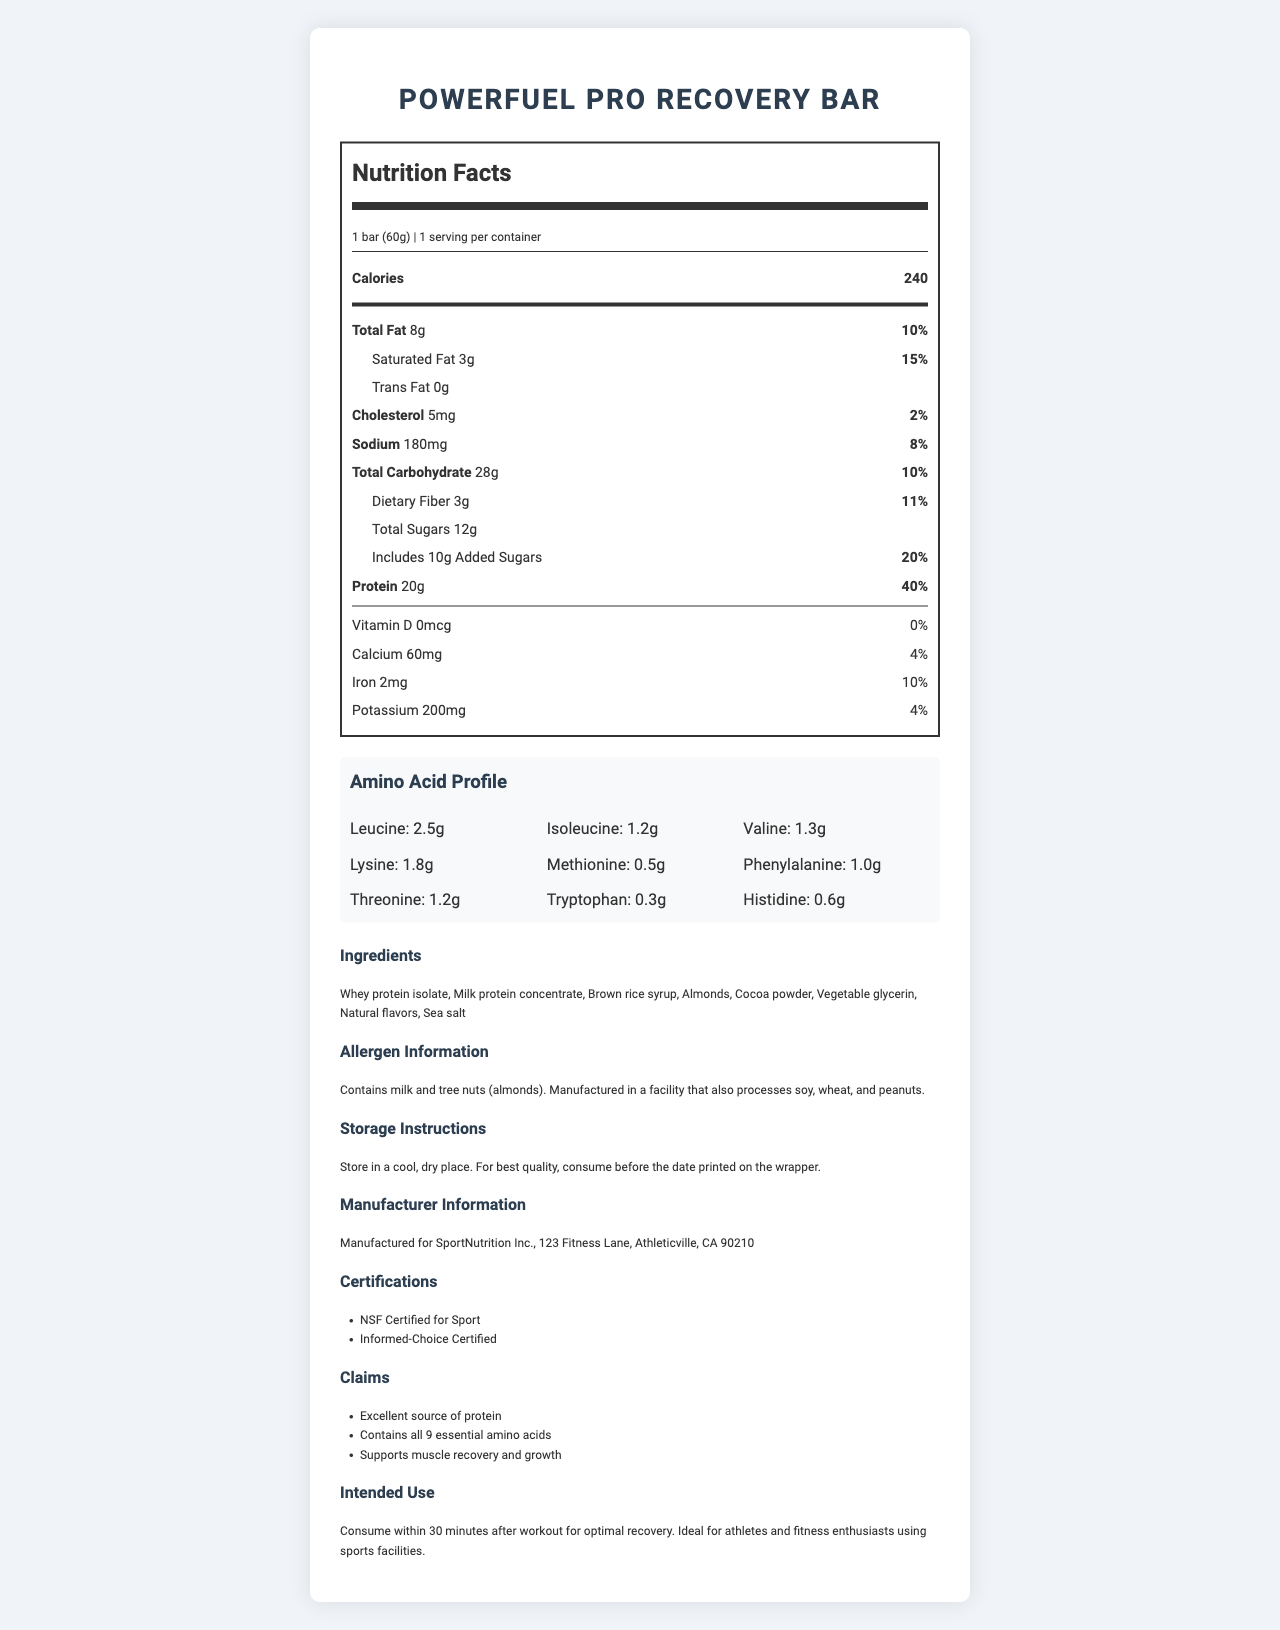what is the serving size of PowerFuel Pro Recovery Bar? According to the nutrition label, the serving size is 1 bar, which weighs 60g.
Answer: 1 bar (60g) How many grams of protein are in one serving? The nutrition label indicates that each serving of the protein bar contains 20 grams of protein.
Answer: 20g What is the percentage daily value of sodium for one serving? The nutrition label shows that the sodium content is 180mg per serving, which is 8% of the daily value.
Answer: 8% Which amino acid is present in the highest amount? The amino acid profile section indicates that Leucine is present in the highest amount, with 2.5 grams per serving.
Answer: Leucine, 2.5g How much dietary fiber does the bar contain? The nutrition facts specify that the bar contains 3 grams of dietary fiber per serving.
Answer: 3g What ingredients are in the PowerFuel Pro Recovery Bar? The ingredient list in the document provides this information.
Answer: Whey protein isolate, Milk protein concentrate, Brown rice syrup, Almonds, Cocoa powder, Vegetable glycerin, Natural flavors, Sea salt How many calories are in one PowerFuel Pro Recovery Bar? The nutrition label mentions that one serving of the bar contains 240 calories.
Answer: 240 calories Which certification does this product have? A. USDA Organic B. NSF Certified for Sport C. Fair Trade Certified The document lists NSF Certified for Sport as one of the certifications that the product has.
Answer: B What is the intended use of this protein bar? A. Before bedtime B. As a meal replacement C. Within 30 minutes after workout The intended use specified in the document is to consume within 30 minutes after a workout for optimal recovery.
Answer: C Does the PowerFuel Pro Recovery Bar contain peanuts? According to the allergen information, the bar contains milk and tree nuts (almonds) but does not list peanuts as an ingredient. However, it is manufactured in a facility that processes peanuts.
Answer: No Does this product provide any Vitamin D? The nutrition facts state that the bar has 0mcg of Vitamin D, equating to 0% of the daily value.
Answer: No Summarize the main purpose of the PowerFuel Pro Recovery Bar document. The detailed nutritional information, ingredient list, amino acid profile, and claims indicate that the bar is designed to support muscle recovery and growth for athletes and fitness enthusiasts.
Answer: The document details the nutritional composition, ingredients, amino acid profile, and usage instructions for the PowerFuel Pro Recovery Bar, emphasizing its role in post-workout recovery due to its high protein content and essential amino acids. What is the amount of calcium in one serving of the bar? The nutrition label indicates that there are 60mg of calcium per serving.
Answer: 60mg Which statement is NOT correct according to the document? A. The bar contains milk. B. The bar is suitable for a keto diet. C. The bar supports muscle recovery. The document does not mention that the bar is suitable for a keto diet. It focuses on muscle recovery and growth.
Answer: B What is the main source of protein in the PowerFuel Pro Recovery Bar? The ingredient list identifies whey protein isolate and milk protein concentrate as the primary sources of protein.
Answer: Whey protein isolate and Milk protein concentrate How should the PowerFuel Pro Recovery Bar be stored for best quality? The storage instructions advise storing the bar in a cool, dry place to maintain its quality.
Answer: Store in a cool, dry place. What is the total carbohydrate content per serving? The nutrition label specifies that there are 28 grams of total carbohydrates in one serving.
Answer: 28g Can this document provide information on the environmental impact of the product? The document does not provide any information regarding the environmental impact of the product.
Answer: Not enough information 